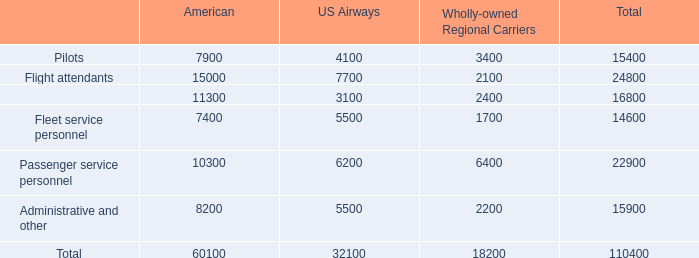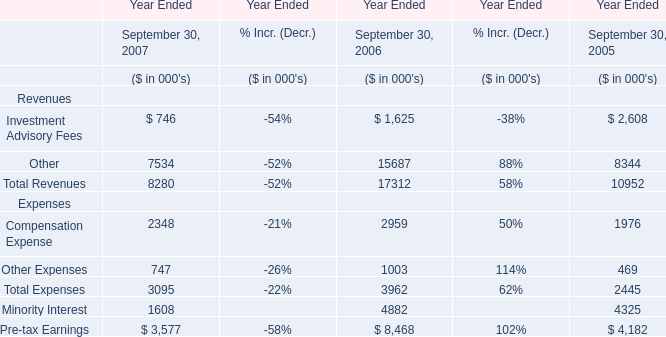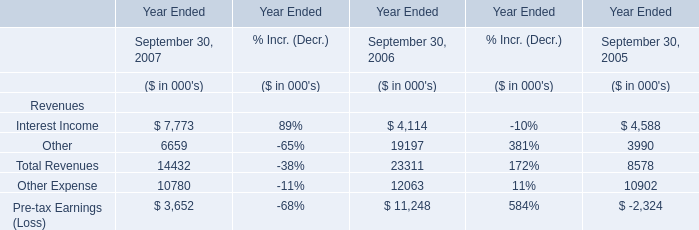As As the chart 1 shows,in the Year Ended September 30 where Compensation Expense is the highest, what's the Total Revenues? (in thousand) 
Answer: 17312. 